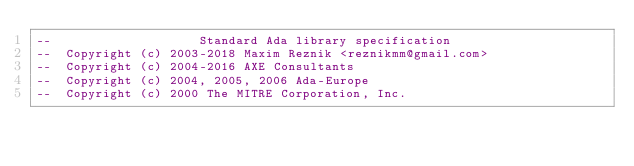Convert code to text. <code><loc_0><loc_0><loc_500><loc_500><_Ada_>--                    Standard Ada library specification
--  Copyright (c) 2003-2018 Maxim Reznik <reznikmm@gmail.com>
--  Copyright (c) 2004-2016 AXE Consultants
--  Copyright (c) 2004, 2005, 2006 Ada-Europe
--  Copyright (c) 2000 The MITRE Corporation, Inc.</code> 